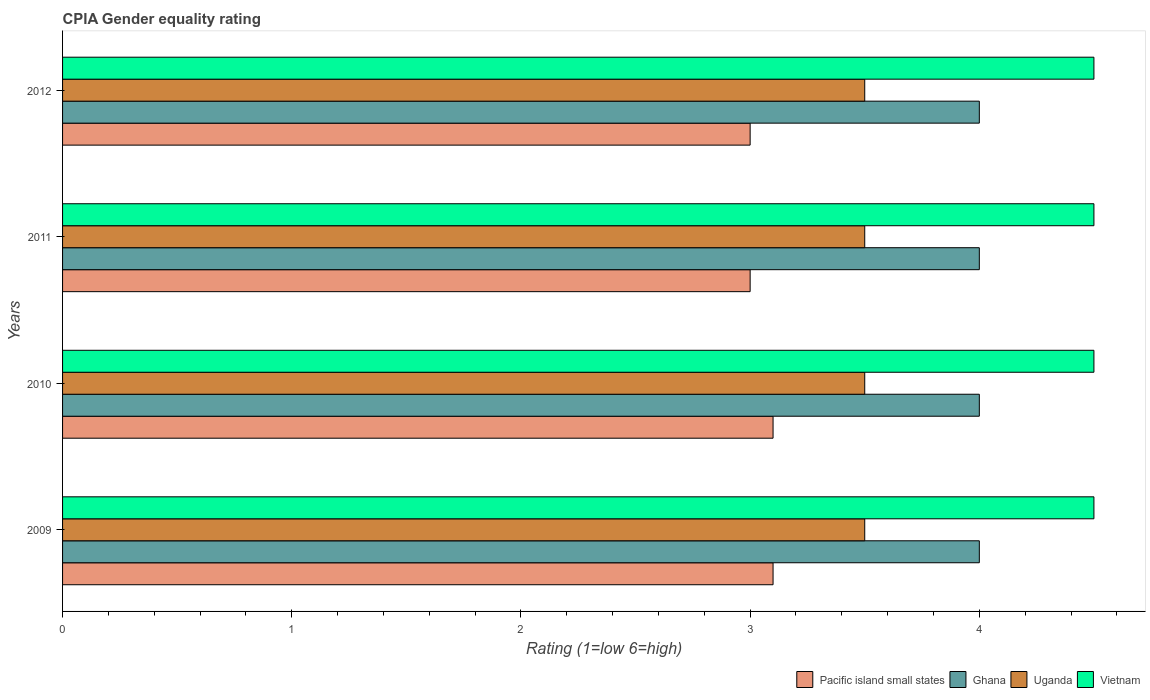How many groups of bars are there?
Give a very brief answer. 4. Are the number of bars per tick equal to the number of legend labels?
Keep it short and to the point. Yes. Are the number of bars on each tick of the Y-axis equal?
Provide a succinct answer. Yes. How many bars are there on the 4th tick from the bottom?
Give a very brief answer. 4. In how many cases, is the number of bars for a given year not equal to the number of legend labels?
Provide a succinct answer. 0. What is the CPIA rating in Uganda in 2011?
Provide a short and direct response. 3.5. Across all years, what is the minimum CPIA rating in Uganda?
Offer a terse response. 3.5. What is the total CPIA rating in Vietnam in the graph?
Provide a succinct answer. 18. What is the average CPIA rating in Pacific island small states per year?
Your response must be concise. 3.05. In the year 2010, what is the difference between the CPIA rating in Ghana and CPIA rating in Pacific island small states?
Make the answer very short. 0.9. In how many years, is the CPIA rating in Ghana greater than 4.4 ?
Offer a very short reply. 0. What is the ratio of the CPIA rating in Vietnam in 2009 to that in 2011?
Offer a terse response. 1. Is the difference between the CPIA rating in Ghana in 2009 and 2012 greater than the difference between the CPIA rating in Pacific island small states in 2009 and 2012?
Keep it short and to the point. No. What is the difference between the highest and the lowest CPIA rating in Uganda?
Offer a very short reply. 0. In how many years, is the CPIA rating in Uganda greater than the average CPIA rating in Uganda taken over all years?
Keep it short and to the point. 0. Is it the case that in every year, the sum of the CPIA rating in Uganda and CPIA rating in Vietnam is greater than the sum of CPIA rating in Pacific island small states and CPIA rating in Ghana?
Your response must be concise. Yes. What does the 4th bar from the top in 2012 represents?
Keep it short and to the point. Pacific island small states. What does the 1st bar from the bottom in 2010 represents?
Your answer should be compact. Pacific island small states. Is it the case that in every year, the sum of the CPIA rating in Ghana and CPIA rating in Pacific island small states is greater than the CPIA rating in Uganda?
Make the answer very short. Yes. How many years are there in the graph?
Your answer should be compact. 4. What is the difference between two consecutive major ticks on the X-axis?
Keep it short and to the point. 1. Does the graph contain any zero values?
Provide a succinct answer. No. What is the title of the graph?
Provide a short and direct response. CPIA Gender equality rating. Does "Guinea-Bissau" appear as one of the legend labels in the graph?
Keep it short and to the point. No. What is the label or title of the X-axis?
Provide a succinct answer. Rating (1=low 6=high). What is the label or title of the Y-axis?
Give a very brief answer. Years. What is the Rating (1=low 6=high) of Ghana in 2009?
Your answer should be compact. 4. What is the Rating (1=low 6=high) of Uganda in 2009?
Ensure brevity in your answer.  3.5. What is the Rating (1=low 6=high) in Ghana in 2010?
Keep it short and to the point. 4. What is the Rating (1=low 6=high) in Vietnam in 2010?
Your answer should be very brief. 4.5. What is the Rating (1=low 6=high) of Pacific island small states in 2011?
Your answer should be very brief. 3. What is the Rating (1=low 6=high) in Uganda in 2011?
Your response must be concise. 3.5. What is the Rating (1=low 6=high) of Vietnam in 2011?
Keep it short and to the point. 4.5. What is the Rating (1=low 6=high) of Uganda in 2012?
Provide a succinct answer. 3.5. What is the Rating (1=low 6=high) of Vietnam in 2012?
Keep it short and to the point. 4.5. Across all years, what is the maximum Rating (1=low 6=high) in Ghana?
Your answer should be very brief. 4. Across all years, what is the minimum Rating (1=low 6=high) of Ghana?
Provide a short and direct response. 4. Across all years, what is the minimum Rating (1=low 6=high) in Uganda?
Your response must be concise. 3.5. What is the total Rating (1=low 6=high) of Ghana in the graph?
Give a very brief answer. 16. What is the total Rating (1=low 6=high) in Vietnam in the graph?
Provide a short and direct response. 18. What is the difference between the Rating (1=low 6=high) in Vietnam in 2009 and that in 2010?
Give a very brief answer. 0. What is the difference between the Rating (1=low 6=high) of Ghana in 2009 and that in 2011?
Offer a terse response. 0. What is the difference between the Rating (1=low 6=high) of Ghana in 2009 and that in 2012?
Your response must be concise. 0. What is the difference between the Rating (1=low 6=high) in Uganda in 2009 and that in 2012?
Offer a terse response. 0. What is the difference between the Rating (1=low 6=high) in Ghana in 2010 and that in 2011?
Give a very brief answer. 0. What is the difference between the Rating (1=low 6=high) of Pacific island small states in 2010 and that in 2012?
Your answer should be compact. 0.1. What is the difference between the Rating (1=low 6=high) in Pacific island small states in 2009 and the Rating (1=low 6=high) in Uganda in 2010?
Offer a terse response. -0.4. What is the difference between the Rating (1=low 6=high) in Ghana in 2009 and the Rating (1=low 6=high) in Uganda in 2010?
Your answer should be very brief. 0.5. What is the difference between the Rating (1=low 6=high) in Ghana in 2009 and the Rating (1=low 6=high) in Vietnam in 2010?
Give a very brief answer. -0.5. What is the difference between the Rating (1=low 6=high) of Pacific island small states in 2009 and the Rating (1=low 6=high) of Uganda in 2011?
Your response must be concise. -0.4. What is the difference between the Rating (1=low 6=high) in Ghana in 2009 and the Rating (1=low 6=high) in Uganda in 2011?
Offer a terse response. 0.5. What is the difference between the Rating (1=low 6=high) in Ghana in 2009 and the Rating (1=low 6=high) in Vietnam in 2011?
Your answer should be very brief. -0.5. What is the difference between the Rating (1=low 6=high) of Uganda in 2009 and the Rating (1=low 6=high) of Vietnam in 2011?
Provide a short and direct response. -1. What is the difference between the Rating (1=low 6=high) of Pacific island small states in 2009 and the Rating (1=low 6=high) of Vietnam in 2012?
Offer a terse response. -1.4. What is the difference between the Rating (1=low 6=high) in Ghana in 2009 and the Rating (1=low 6=high) in Vietnam in 2012?
Offer a very short reply. -0.5. What is the difference between the Rating (1=low 6=high) in Uganda in 2009 and the Rating (1=low 6=high) in Vietnam in 2012?
Your answer should be compact. -1. What is the difference between the Rating (1=low 6=high) in Ghana in 2010 and the Rating (1=low 6=high) in Uganda in 2011?
Your answer should be very brief. 0.5. What is the difference between the Rating (1=low 6=high) of Ghana in 2010 and the Rating (1=low 6=high) of Vietnam in 2011?
Provide a succinct answer. -0.5. What is the difference between the Rating (1=low 6=high) in Pacific island small states in 2010 and the Rating (1=low 6=high) in Ghana in 2012?
Keep it short and to the point. -0.9. What is the difference between the Rating (1=low 6=high) in Pacific island small states in 2010 and the Rating (1=low 6=high) in Vietnam in 2012?
Your answer should be compact. -1.4. What is the difference between the Rating (1=low 6=high) of Ghana in 2010 and the Rating (1=low 6=high) of Vietnam in 2012?
Your answer should be compact. -0.5. What is the difference between the Rating (1=low 6=high) of Uganda in 2010 and the Rating (1=low 6=high) of Vietnam in 2012?
Ensure brevity in your answer.  -1. What is the difference between the Rating (1=low 6=high) in Pacific island small states in 2011 and the Rating (1=low 6=high) in Uganda in 2012?
Your response must be concise. -0.5. What is the difference between the Rating (1=low 6=high) in Pacific island small states in 2011 and the Rating (1=low 6=high) in Vietnam in 2012?
Ensure brevity in your answer.  -1.5. What is the difference between the Rating (1=low 6=high) in Ghana in 2011 and the Rating (1=low 6=high) in Uganda in 2012?
Your response must be concise. 0.5. What is the average Rating (1=low 6=high) of Pacific island small states per year?
Give a very brief answer. 3.05. What is the average Rating (1=low 6=high) in Ghana per year?
Provide a short and direct response. 4. What is the average Rating (1=low 6=high) in Uganda per year?
Your response must be concise. 3.5. What is the average Rating (1=low 6=high) of Vietnam per year?
Your answer should be compact. 4.5. In the year 2009, what is the difference between the Rating (1=low 6=high) in Pacific island small states and Rating (1=low 6=high) in Uganda?
Keep it short and to the point. -0.4. In the year 2010, what is the difference between the Rating (1=low 6=high) of Pacific island small states and Rating (1=low 6=high) of Vietnam?
Provide a succinct answer. -1.4. In the year 2010, what is the difference between the Rating (1=low 6=high) of Ghana and Rating (1=low 6=high) of Uganda?
Your answer should be very brief. 0.5. In the year 2011, what is the difference between the Rating (1=low 6=high) in Pacific island small states and Rating (1=low 6=high) in Uganda?
Make the answer very short. -0.5. In the year 2011, what is the difference between the Rating (1=low 6=high) of Pacific island small states and Rating (1=low 6=high) of Vietnam?
Ensure brevity in your answer.  -1.5. In the year 2011, what is the difference between the Rating (1=low 6=high) in Ghana and Rating (1=low 6=high) in Uganda?
Your answer should be very brief. 0.5. In the year 2012, what is the difference between the Rating (1=low 6=high) of Pacific island small states and Rating (1=low 6=high) of Ghana?
Your answer should be very brief. -1. In the year 2012, what is the difference between the Rating (1=low 6=high) in Pacific island small states and Rating (1=low 6=high) in Vietnam?
Offer a very short reply. -1.5. In the year 2012, what is the difference between the Rating (1=low 6=high) of Ghana and Rating (1=low 6=high) of Uganda?
Provide a succinct answer. 0.5. In the year 2012, what is the difference between the Rating (1=low 6=high) of Uganda and Rating (1=low 6=high) of Vietnam?
Your response must be concise. -1. What is the ratio of the Rating (1=low 6=high) of Ghana in 2009 to that in 2010?
Keep it short and to the point. 1. What is the ratio of the Rating (1=low 6=high) in Vietnam in 2009 to that in 2011?
Make the answer very short. 1. What is the ratio of the Rating (1=low 6=high) of Pacific island small states in 2009 to that in 2012?
Give a very brief answer. 1.03. What is the ratio of the Rating (1=low 6=high) of Ghana in 2009 to that in 2012?
Offer a terse response. 1. What is the ratio of the Rating (1=low 6=high) of Vietnam in 2009 to that in 2012?
Give a very brief answer. 1. What is the ratio of the Rating (1=low 6=high) in Ghana in 2010 to that in 2011?
Your response must be concise. 1. What is the ratio of the Rating (1=low 6=high) of Uganda in 2010 to that in 2011?
Offer a terse response. 1. What is the ratio of the Rating (1=low 6=high) of Vietnam in 2010 to that in 2011?
Offer a terse response. 1. What is the ratio of the Rating (1=low 6=high) in Pacific island small states in 2011 to that in 2012?
Your response must be concise. 1. What is the ratio of the Rating (1=low 6=high) in Ghana in 2011 to that in 2012?
Your answer should be very brief. 1. What is the difference between the highest and the second highest Rating (1=low 6=high) of Ghana?
Your answer should be very brief. 0. What is the difference between the highest and the second highest Rating (1=low 6=high) in Uganda?
Provide a succinct answer. 0. What is the difference between the highest and the second highest Rating (1=low 6=high) in Vietnam?
Ensure brevity in your answer.  0. What is the difference between the highest and the lowest Rating (1=low 6=high) in Pacific island small states?
Give a very brief answer. 0.1. What is the difference between the highest and the lowest Rating (1=low 6=high) of Ghana?
Make the answer very short. 0. What is the difference between the highest and the lowest Rating (1=low 6=high) in Uganda?
Ensure brevity in your answer.  0. 